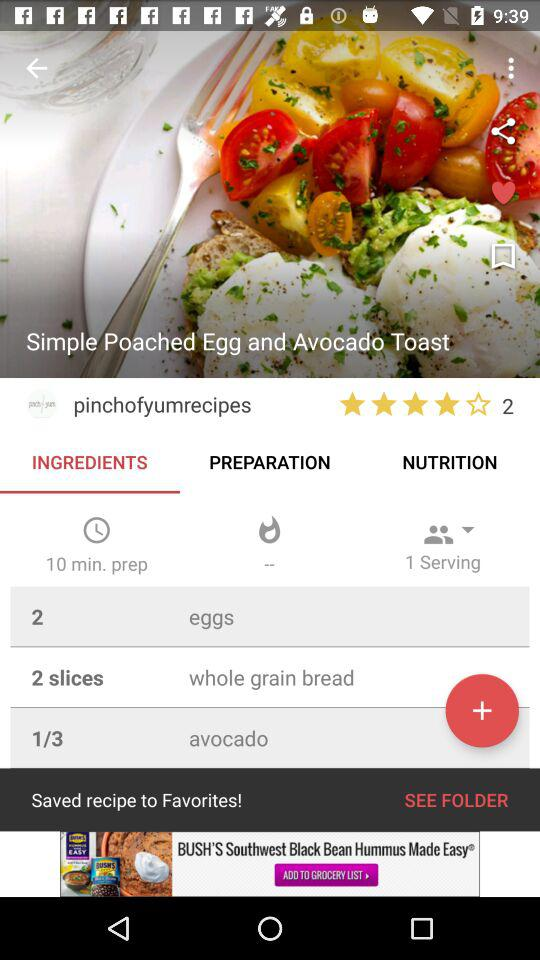How many eggs are required for the dish? There are 2 eggs required. 